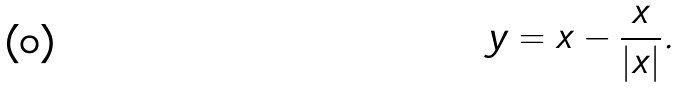Convert formula to latex. <formula><loc_0><loc_0><loc_500><loc_500>y = x - \frac { x } { | x | } .</formula> 